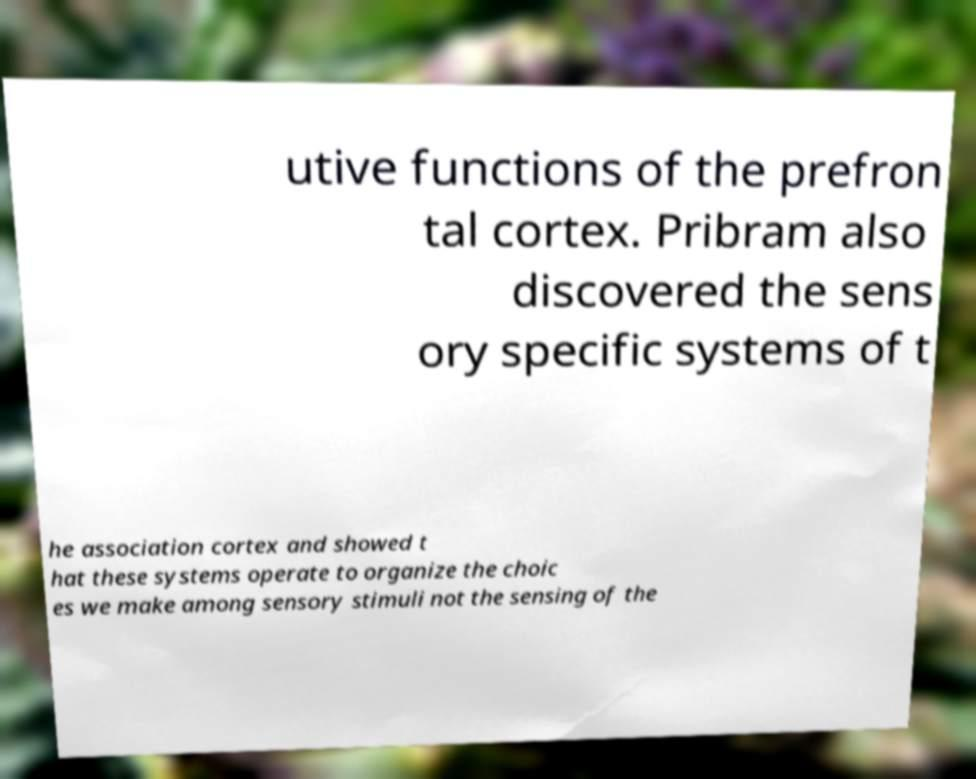For documentation purposes, I need the text within this image transcribed. Could you provide that? utive functions of the prefron tal cortex. Pribram also discovered the sens ory specific systems of t he association cortex and showed t hat these systems operate to organize the choic es we make among sensory stimuli not the sensing of the 